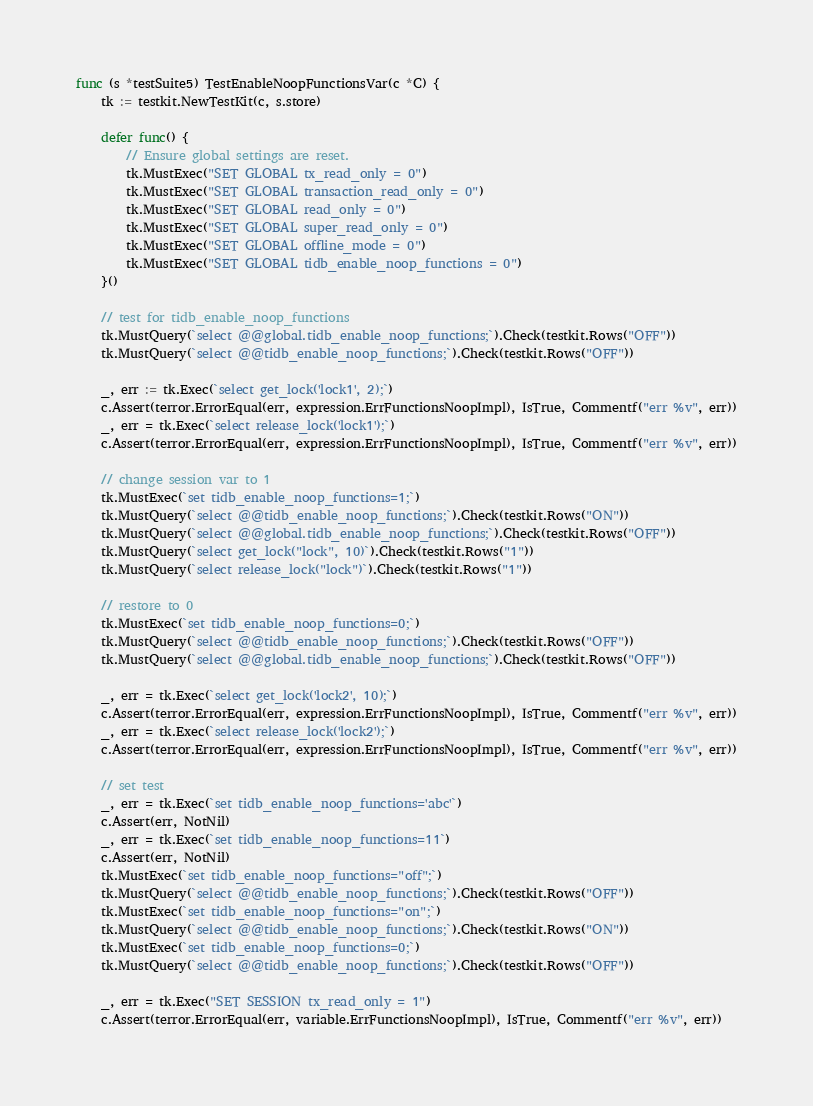<code> <loc_0><loc_0><loc_500><loc_500><_Go_>func (s *testSuite5) TestEnableNoopFunctionsVar(c *C) {
	tk := testkit.NewTestKit(c, s.store)

	defer func() {
		// Ensure global settings are reset.
		tk.MustExec("SET GLOBAL tx_read_only = 0")
		tk.MustExec("SET GLOBAL transaction_read_only = 0")
		tk.MustExec("SET GLOBAL read_only = 0")
		tk.MustExec("SET GLOBAL super_read_only = 0")
		tk.MustExec("SET GLOBAL offline_mode = 0")
		tk.MustExec("SET GLOBAL tidb_enable_noop_functions = 0")
	}()

	// test for tidb_enable_noop_functions
	tk.MustQuery(`select @@global.tidb_enable_noop_functions;`).Check(testkit.Rows("OFF"))
	tk.MustQuery(`select @@tidb_enable_noop_functions;`).Check(testkit.Rows("OFF"))

	_, err := tk.Exec(`select get_lock('lock1', 2);`)
	c.Assert(terror.ErrorEqual(err, expression.ErrFunctionsNoopImpl), IsTrue, Commentf("err %v", err))
	_, err = tk.Exec(`select release_lock('lock1');`)
	c.Assert(terror.ErrorEqual(err, expression.ErrFunctionsNoopImpl), IsTrue, Commentf("err %v", err))

	// change session var to 1
	tk.MustExec(`set tidb_enable_noop_functions=1;`)
	tk.MustQuery(`select @@tidb_enable_noop_functions;`).Check(testkit.Rows("ON"))
	tk.MustQuery(`select @@global.tidb_enable_noop_functions;`).Check(testkit.Rows("OFF"))
	tk.MustQuery(`select get_lock("lock", 10)`).Check(testkit.Rows("1"))
	tk.MustQuery(`select release_lock("lock")`).Check(testkit.Rows("1"))

	// restore to 0
	tk.MustExec(`set tidb_enable_noop_functions=0;`)
	tk.MustQuery(`select @@tidb_enable_noop_functions;`).Check(testkit.Rows("OFF"))
	tk.MustQuery(`select @@global.tidb_enable_noop_functions;`).Check(testkit.Rows("OFF"))

	_, err = tk.Exec(`select get_lock('lock2', 10);`)
	c.Assert(terror.ErrorEqual(err, expression.ErrFunctionsNoopImpl), IsTrue, Commentf("err %v", err))
	_, err = tk.Exec(`select release_lock('lock2');`)
	c.Assert(terror.ErrorEqual(err, expression.ErrFunctionsNoopImpl), IsTrue, Commentf("err %v", err))

	// set test
	_, err = tk.Exec(`set tidb_enable_noop_functions='abc'`)
	c.Assert(err, NotNil)
	_, err = tk.Exec(`set tidb_enable_noop_functions=11`)
	c.Assert(err, NotNil)
	tk.MustExec(`set tidb_enable_noop_functions="off";`)
	tk.MustQuery(`select @@tidb_enable_noop_functions;`).Check(testkit.Rows("OFF"))
	tk.MustExec(`set tidb_enable_noop_functions="on";`)
	tk.MustQuery(`select @@tidb_enable_noop_functions;`).Check(testkit.Rows("ON"))
	tk.MustExec(`set tidb_enable_noop_functions=0;`)
	tk.MustQuery(`select @@tidb_enable_noop_functions;`).Check(testkit.Rows("OFF"))

	_, err = tk.Exec("SET SESSION tx_read_only = 1")
	c.Assert(terror.ErrorEqual(err, variable.ErrFunctionsNoopImpl), IsTrue, Commentf("err %v", err))
</code> 